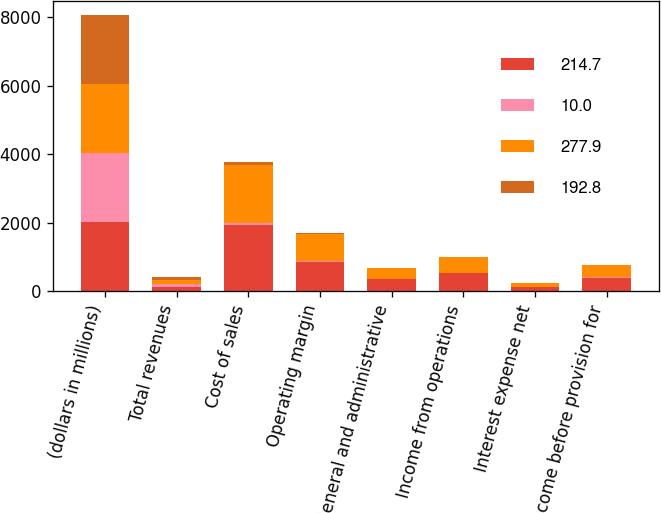Convert chart to OTSL. <chart><loc_0><loc_0><loc_500><loc_500><stacked_bar_chart><ecel><fcel>(dollars in millions)<fcel>Total revenues<fcel>Cost of sales<fcel>Operating margin<fcel>General and administrative<fcel>Income from operations<fcel>Interest expense net<fcel>Income before provision for<nl><fcel>214.7<fcel>2017<fcel>115.25<fcel>1922<fcel>866<fcel>344.8<fcel>521.2<fcel>121.1<fcel>400.2<nl><fcel>10<fcel>2017<fcel>100<fcel>68.9<fcel>31.1<fcel>12.4<fcel>18.7<fcel>4.3<fcel>14.4<nl><fcel>277.9<fcel>2016<fcel>115.25<fcel>1704.9<fcel>767.7<fcel>313.6<fcel>454<fcel>109.4<fcel>344.7<nl><fcel>192.8<fcel>2016<fcel>100<fcel>69<fcel>31<fcel>12.7<fcel>18.3<fcel>4.4<fcel>13.9<nl></chart> 